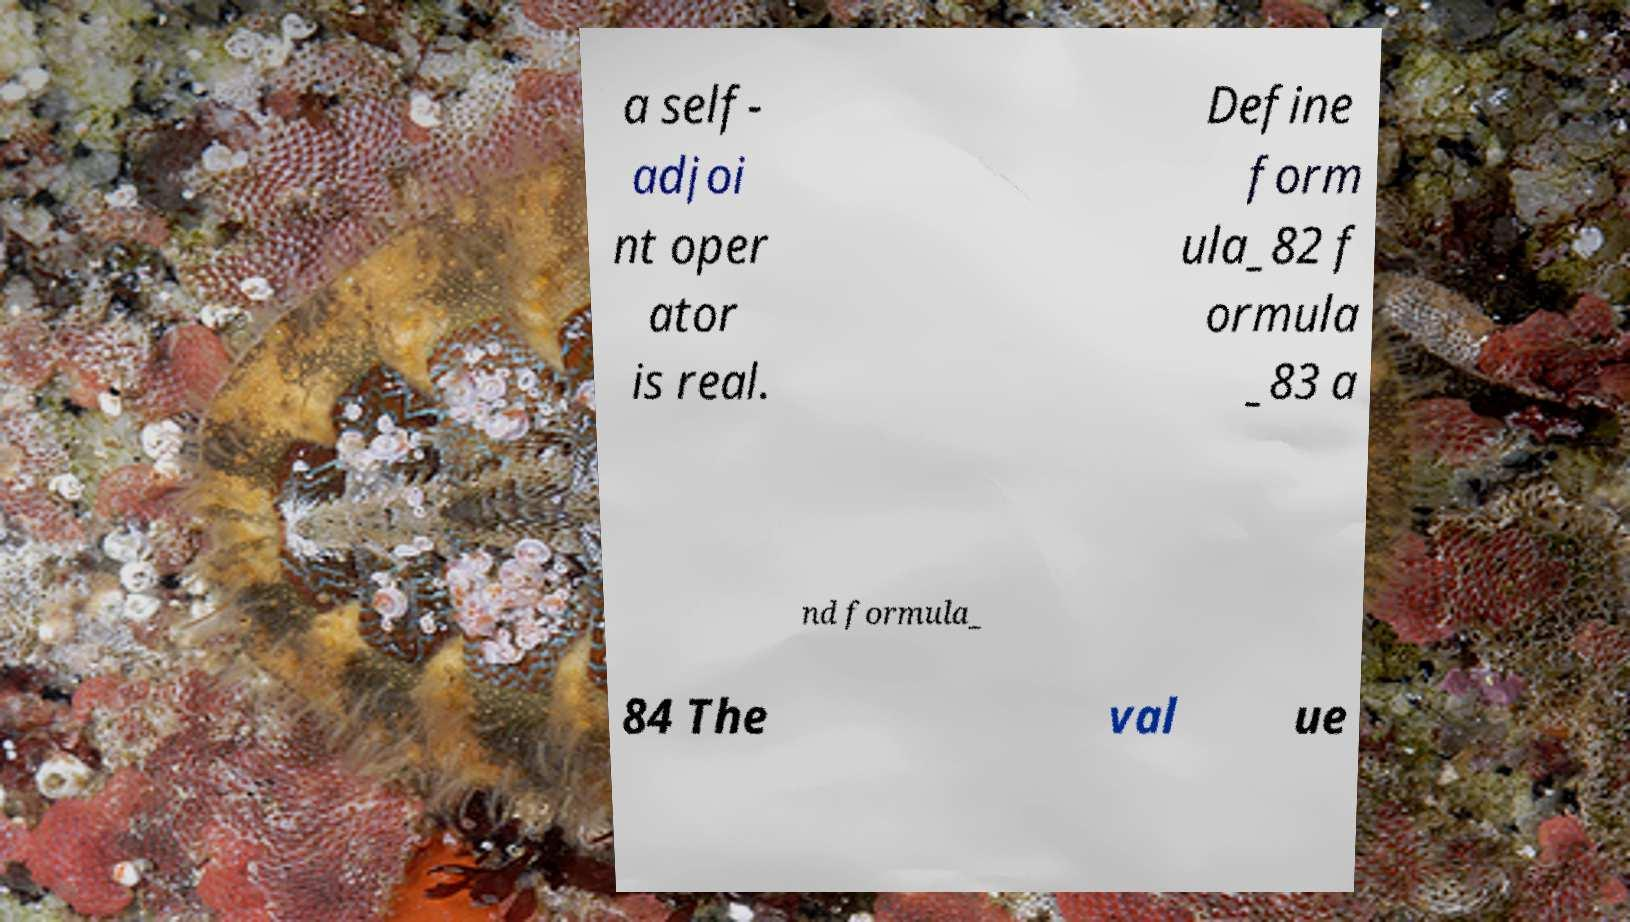Could you assist in decoding the text presented in this image and type it out clearly? a self- adjoi nt oper ator is real. Define form ula_82 f ormula _83 a nd formula_ 84 The val ue 